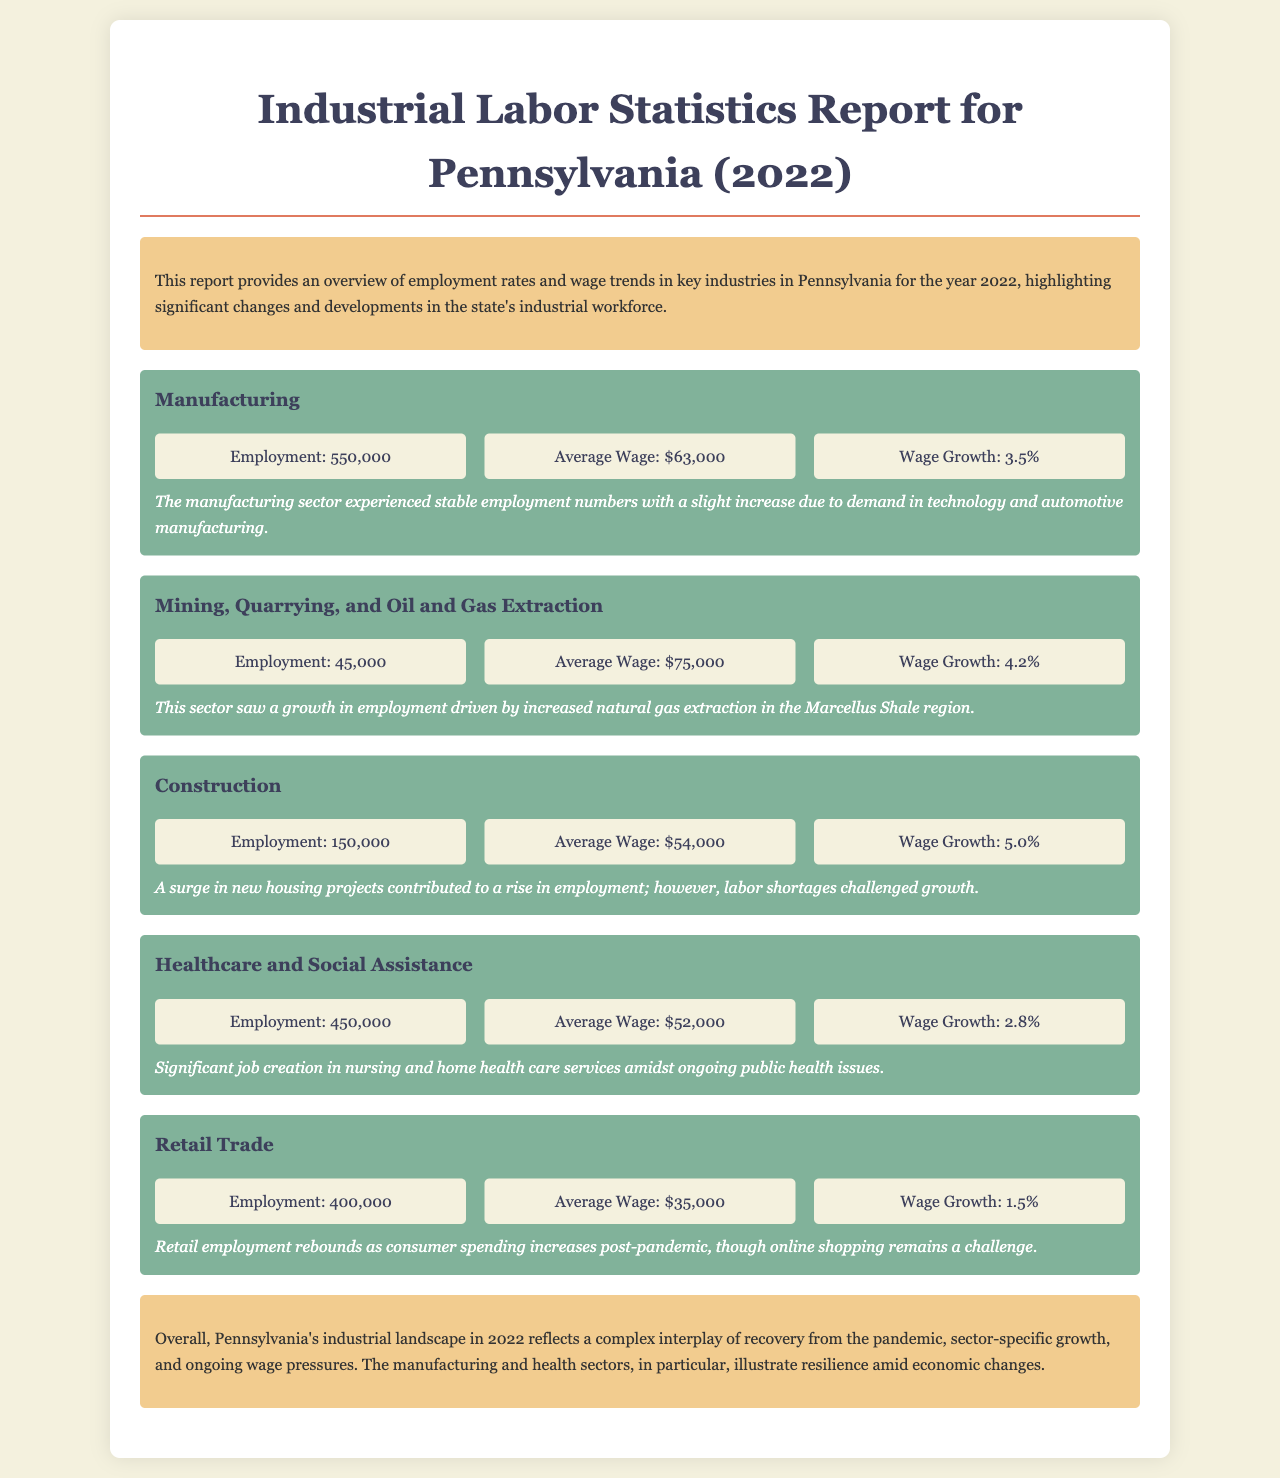What was the employment number in the Manufacturing sector? The employment number in the Manufacturing sector is directly stated in the document as 550,000.
Answer: 550,000 What is the average wage in the Mining, Quarrying, and Oil and Gas Extraction sector? The average wage for the Mining sector is mentioned in the document as $75,000.
Answer: $75,000 What percentage was the wage growth in the Construction industry? The wage growth for the Construction industry can be found in the document as 5.0%.
Answer: 5.0% Which sector experienced the highest average wage in 2022? The sector with the highest average wage is identified in the document as Mining, Quarrying, and Oil and Gas Extraction, which has an average wage of $75,000.
Answer: Mining, Quarrying, and Oil and Gas Extraction What notable trend affected Retail Trade employment? A notable trend affecting Retail Trade employment is the rebound as stated in the document: consumer spending increases post-pandemic.
Answer: Rebound in consumer spending How many people were employed in Healthcare and Social Assistance? The document explicitly states that employment in Healthcare and Social Assistance was 450,000.
Answer: 450,000 What challenges were noted in the Construction sector? The document mentions labor shortages as a challenge in the Construction sector.
Answer: Labor shortages What is the employment figure for the Retail Trade sector? The document provides the employment figure for the Retail Trade sector as 400,000.
Answer: 400,000 